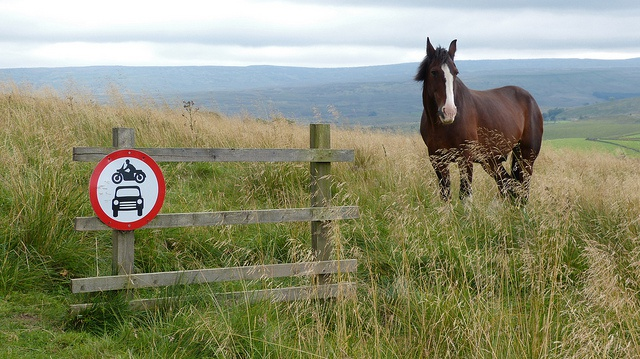Describe the objects in this image and their specific colors. I can see a horse in white, black, gray, and maroon tones in this image. 